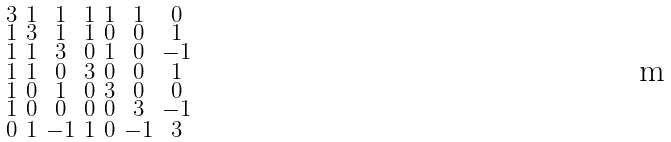<formula> <loc_0><loc_0><loc_500><loc_500>\begin{smallmatrix} 3 & 1 & 1 & 1 & 1 & 1 & 0 \\ 1 & 3 & 1 & 1 & 0 & 0 & 1 \\ 1 & 1 & 3 & 0 & 1 & 0 & - 1 \\ 1 & 1 & 0 & 3 & 0 & 0 & 1 \\ 1 & 0 & 1 & 0 & 3 & 0 & 0 \\ 1 & 0 & 0 & 0 & 0 & 3 & - 1 \\ 0 & 1 & - 1 & 1 & 0 & - 1 & 3 \end{smallmatrix}</formula> 